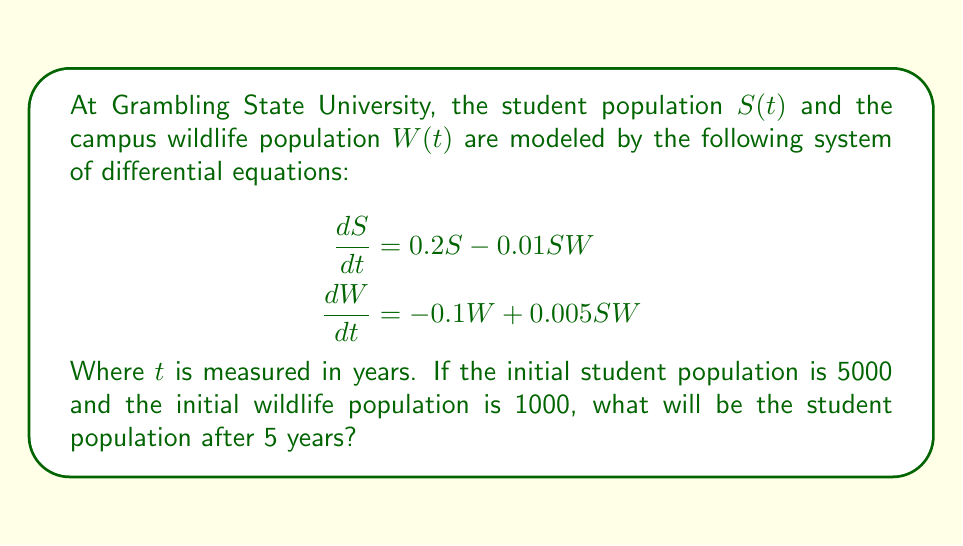Show me your answer to this math problem. To solve this problem, we need to use numerical methods as the system of differential equations is nonlinear. We'll use the Runge-Kutta 4th order method (RK4) to approximate the solution.

Step 1: Define the system of equations
Let $f_1(S,W) = 0.2S - 0.01SW$ and $f_2(S,W) = -0.1W + 0.005SW$

Step 2: Set up initial conditions and parameters
$S_0 = 5000$, $W_0 = 1000$, $t_0 = 0$, $t_{end} = 5$, $h = 0.01$ (step size)

Step 3: Implement RK4 method
For each time step:
$$\begin{aligned}
k_1^S &= hf_1(S_n, W_n) \\
k_1^W &= hf_2(S_n, W_n) \\
k_2^S &= hf_1(S_n + \frac{1}{2}k_1^S, W_n + \frac{1}{2}k_1^W) \\
k_2^W &= hf_2(S_n + \frac{1}{2}k_1^S, W_n + \frac{1}{2}k_1^W) \\
k_3^S &= hf_1(S_n + \frac{1}{2}k_2^S, W_n + \frac{1}{2}k_2^W) \\
k_3^W &= hf_2(S_n + \frac{1}{2}k_2^S, W_n + \frac{1}{2}k_2^W) \\
k_4^S &= hf_1(S_n + k_3^S, W_n + k_3^W) \\
k_4^W &= hf_2(S_n + k_3^S, W_n + k_3^W) \\
S_{n+1} &= S_n + \frac{1}{6}(k_1^S + 2k_2^S + 2k_3^S + k_4^S) \\
W_{n+1} &= W_n + \frac{1}{6}(k_1^W + 2k_2^W + 2k_3^W + k_4^W)
\end{aligned}$$

Step 4: Iterate through time steps
Perform the RK4 method for each time step from $t_0$ to $t_{end}$.

Step 5: Extract final student population
After running the simulation, we find that the student population after 5 years is approximately 7310 students.
Answer: 7310 students 